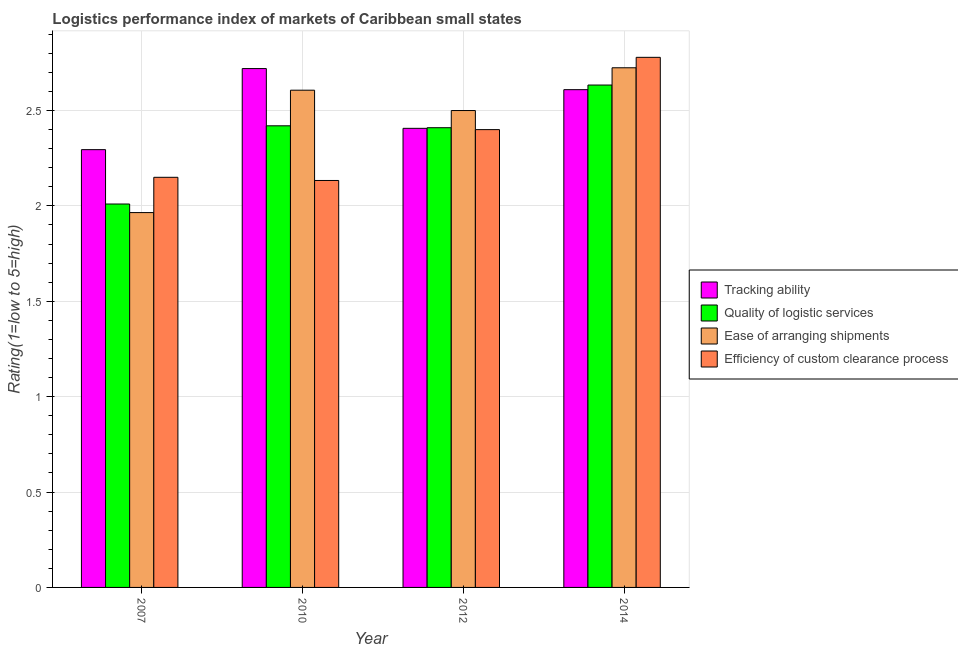How many different coloured bars are there?
Provide a succinct answer. 4. How many groups of bars are there?
Make the answer very short. 4. How many bars are there on the 4th tick from the right?
Keep it short and to the point. 4. What is the label of the 1st group of bars from the left?
Your answer should be compact. 2007. In how many cases, is the number of bars for a given year not equal to the number of legend labels?
Provide a short and direct response. 0. What is the lpi rating of quality of logistic services in 2010?
Offer a terse response. 2.42. Across all years, what is the maximum lpi rating of tracking ability?
Ensure brevity in your answer.  2.72. Across all years, what is the minimum lpi rating of quality of logistic services?
Your answer should be compact. 2.01. In which year was the lpi rating of tracking ability maximum?
Provide a short and direct response. 2010. What is the total lpi rating of efficiency of custom clearance process in the graph?
Make the answer very short. 9.46. What is the difference between the lpi rating of ease of arranging shipments in 2012 and that in 2014?
Your response must be concise. -0.22. What is the difference between the lpi rating of quality of logistic services in 2014 and the lpi rating of tracking ability in 2007?
Your response must be concise. 0.62. What is the average lpi rating of tracking ability per year?
Your answer should be very brief. 2.51. What is the ratio of the lpi rating of efficiency of custom clearance process in 2007 to that in 2012?
Your response must be concise. 0.9. Is the difference between the lpi rating of quality of logistic services in 2007 and 2012 greater than the difference between the lpi rating of efficiency of custom clearance process in 2007 and 2012?
Your answer should be compact. No. What is the difference between the highest and the second highest lpi rating of ease of arranging shipments?
Your response must be concise. 0.12. What is the difference between the highest and the lowest lpi rating of quality of logistic services?
Give a very brief answer. 0.62. In how many years, is the lpi rating of ease of arranging shipments greater than the average lpi rating of ease of arranging shipments taken over all years?
Your answer should be compact. 3. Is the sum of the lpi rating of quality of logistic services in 2010 and 2012 greater than the maximum lpi rating of ease of arranging shipments across all years?
Your answer should be very brief. Yes. What does the 3rd bar from the left in 2014 represents?
Your response must be concise. Ease of arranging shipments. What does the 3rd bar from the right in 2007 represents?
Your answer should be compact. Quality of logistic services. How many bars are there?
Your response must be concise. 16. Are all the bars in the graph horizontal?
Offer a terse response. No. Are the values on the major ticks of Y-axis written in scientific E-notation?
Provide a succinct answer. No. Does the graph contain any zero values?
Your response must be concise. No. Does the graph contain grids?
Offer a very short reply. Yes. Where does the legend appear in the graph?
Give a very brief answer. Center right. How many legend labels are there?
Offer a terse response. 4. What is the title of the graph?
Keep it short and to the point. Logistics performance index of markets of Caribbean small states. Does "Corruption" appear as one of the legend labels in the graph?
Give a very brief answer. No. What is the label or title of the Y-axis?
Make the answer very short. Rating(1=low to 5=high). What is the Rating(1=low to 5=high) in Tracking ability in 2007?
Ensure brevity in your answer.  2.29. What is the Rating(1=low to 5=high) of Quality of logistic services in 2007?
Provide a short and direct response. 2.01. What is the Rating(1=low to 5=high) in Ease of arranging shipments in 2007?
Your answer should be compact. 1.97. What is the Rating(1=low to 5=high) in Efficiency of custom clearance process in 2007?
Ensure brevity in your answer.  2.15. What is the Rating(1=low to 5=high) of Tracking ability in 2010?
Provide a short and direct response. 2.72. What is the Rating(1=low to 5=high) in Quality of logistic services in 2010?
Give a very brief answer. 2.42. What is the Rating(1=low to 5=high) of Ease of arranging shipments in 2010?
Your answer should be very brief. 2.61. What is the Rating(1=low to 5=high) in Efficiency of custom clearance process in 2010?
Offer a very short reply. 2.13. What is the Rating(1=low to 5=high) of Tracking ability in 2012?
Keep it short and to the point. 2.41. What is the Rating(1=low to 5=high) of Quality of logistic services in 2012?
Provide a short and direct response. 2.41. What is the Rating(1=low to 5=high) in Efficiency of custom clearance process in 2012?
Give a very brief answer. 2.4. What is the Rating(1=low to 5=high) of Tracking ability in 2014?
Offer a terse response. 2.61. What is the Rating(1=low to 5=high) of Quality of logistic services in 2014?
Offer a very short reply. 2.63. What is the Rating(1=low to 5=high) in Ease of arranging shipments in 2014?
Give a very brief answer. 2.72. What is the Rating(1=low to 5=high) of Efficiency of custom clearance process in 2014?
Keep it short and to the point. 2.78. Across all years, what is the maximum Rating(1=low to 5=high) in Tracking ability?
Provide a short and direct response. 2.72. Across all years, what is the maximum Rating(1=low to 5=high) in Quality of logistic services?
Provide a short and direct response. 2.63. Across all years, what is the maximum Rating(1=low to 5=high) of Ease of arranging shipments?
Keep it short and to the point. 2.72. Across all years, what is the maximum Rating(1=low to 5=high) in Efficiency of custom clearance process?
Your answer should be very brief. 2.78. Across all years, what is the minimum Rating(1=low to 5=high) of Tracking ability?
Provide a succinct answer. 2.29. Across all years, what is the minimum Rating(1=low to 5=high) of Quality of logistic services?
Keep it short and to the point. 2.01. Across all years, what is the minimum Rating(1=low to 5=high) in Ease of arranging shipments?
Provide a succinct answer. 1.97. Across all years, what is the minimum Rating(1=low to 5=high) of Efficiency of custom clearance process?
Ensure brevity in your answer.  2.13. What is the total Rating(1=low to 5=high) of Tracking ability in the graph?
Offer a terse response. 10.03. What is the total Rating(1=low to 5=high) of Quality of logistic services in the graph?
Your answer should be compact. 9.47. What is the total Rating(1=low to 5=high) in Ease of arranging shipments in the graph?
Your answer should be compact. 9.8. What is the total Rating(1=low to 5=high) of Efficiency of custom clearance process in the graph?
Provide a succinct answer. 9.46. What is the difference between the Rating(1=low to 5=high) in Tracking ability in 2007 and that in 2010?
Ensure brevity in your answer.  -0.42. What is the difference between the Rating(1=low to 5=high) of Quality of logistic services in 2007 and that in 2010?
Your answer should be very brief. -0.41. What is the difference between the Rating(1=low to 5=high) in Ease of arranging shipments in 2007 and that in 2010?
Keep it short and to the point. -0.64. What is the difference between the Rating(1=low to 5=high) of Efficiency of custom clearance process in 2007 and that in 2010?
Provide a succinct answer. 0.02. What is the difference between the Rating(1=low to 5=high) in Tracking ability in 2007 and that in 2012?
Offer a very short reply. -0.11. What is the difference between the Rating(1=low to 5=high) in Ease of arranging shipments in 2007 and that in 2012?
Ensure brevity in your answer.  -0.54. What is the difference between the Rating(1=low to 5=high) of Efficiency of custom clearance process in 2007 and that in 2012?
Give a very brief answer. -0.25. What is the difference between the Rating(1=low to 5=high) in Tracking ability in 2007 and that in 2014?
Offer a terse response. -0.31. What is the difference between the Rating(1=low to 5=high) of Quality of logistic services in 2007 and that in 2014?
Offer a terse response. -0.62. What is the difference between the Rating(1=low to 5=high) of Ease of arranging shipments in 2007 and that in 2014?
Offer a terse response. -0.76. What is the difference between the Rating(1=low to 5=high) in Efficiency of custom clearance process in 2007 and that in 2014?
Ensure brevity in your answer.  -0.63. What is the difference between the Rating(1=low to 5=high) of Tracking ability in 2010 and that in 2012?
Ensure brevity in your answer.  0.31. What is the difference between the Rating(1=low to 5=high) in Ease of arranging shipments in 2010 and that in 2012?
Make the answer very short. 0.11. What is the difference between the Rating(1=low to 5=high) in Efficiency of custom clearance process in 2010 and that in 2012?
Provide a short and direct response. -0.27. What is the difference between the Rating(1=low to 5=high) in Tracking ability in 2010 and that in 2014?
Provide a succinct answer. 0.11. What is the difference between the Rating(1=low to 5=high) in Quality of logistic services in 2010 and that in 2014?
Keep it short and to the point. -0.21. What is the difference between the Rating(1=low to 5=high) in Ease of arranging shipments in 2010 and that in 2014?
Make the answer very short. -0.12. What is the difference between the Rating(1=low to 5=high) in Efficiency of custom clearance process in 2010 and that in 2014?
Your answer should be very brief. -0.65. What is the difference between the Rating(1=low to 5=high) of Tracking ability in 2012 and that in 2014?
Your answer should be very brief. -0.2. What is the difference between the Rating(1=low to 5=high) of Quality of logistic services in 2012 and that in 2014?
Your response must be concise. -0.22. What is the difference between the Rating(1=low to 5=high) of Ease of arranging shipments in 2012 and that in 2014?
Your response must be concise. -0.22. What is the difference between the Rating(1=low to 5=high) in Efficiency of custom clearance process in 2012 and that in 2014?
Make the answer very short. -0.38. What is the difference between the Rating(1=low to 5=high) in Tracking ability in 2007 and the Rating(1=low to 5=high) in Quality of logistic services in 2010?
Your answer should be compact. -0.12. What is the difference between the Rating(1=low to 5=high) of Tracking ability in 2007 and the Rating(1=low to 5=high) of Ease of arranging shipments in 2010?
Ensure brevity in your answer.  -0.31. What is the difference between the Rating(1=low to 5=high) of Tracking ability in 2007 and the Rating(1=low to 5=high) of Efficiency of custom clearance process in 2010?
Offer a very short reply. 0.16. What is the difference between the Rating(1=low to 5=high) of Quality of logistic services in 2007 and the Rating(1=low to 5=high) of Ease of arranging shipments in 2010?
Provide a short and direct response. -0.6. What is the difference between the Rating(1=low to 5=high) in Quality of logistic services in 2007 and the Rating(1=low to 5=high) in Efficiency of custom clearance process in 2010?
Make the answer very short. -0.12. What is the difference between the Rating(1=low to 5=high) in Ease of arranging shipments in 2007 and the Rating(1=low to 5=high) in Efficiency of custom clearance process in 2010?
Make the answer very short. -0.17. What is the difference between the Rating(1=low to 5=high) in Tracking ability in 2007 and the Rating(1=low to 5=high) in Quality of logistic services in 2012?
Provide a short and direct response. -0.12. What is the difference between the Rating(1=low to 5=high) in Tracking ability in 2007 and the Rating(1=low to 5=high) in Ease of arranging shipments in 2012?
Your answer should be compact. -0.2. What is the difference between the Rating(1=low to 5=high) of Tracking ability in 2007 and the Rating(1=low to 5=high) of Efficiency of custom clearance process in 2012?
Keep it short and to the point. -0.1. What is the difference between the Rating(1=low to 5=high) of Quality of logistic services in 2007 and the Rating(1=low to 5=high) of Ease of arranging shipments in 2012?
Keep it short and to the point. -0.49. What is the difference between the Rating(1=low to 5=high) in Quality of logistic services in 2007 and the Rating(1=low to 5=high) in Efficiency of custom clearance process in 2012?
Your answer should be very brief. -0.39. What is the difference between the Rating(1=low to 5=high) in Ease of arranging shipments in 2007 and the Rating(1=low to 5=high) in Efficiency of custom clearance process in 2012?
Keep it short and to the point. -0.43. What is the difference between the Rating(1=low to 5=high) of Tracking ability in 2007 and the Rating(1=low to 5=high) of Quality of logistic services in 2014?
Ensure brevity in your answer.  -0.34. What is the difference between the Rating(1=low to 5=high) in Tracking ability in 2007 and the Rating(1=low to 5=high) in Ease of arranging shipments in 2014?
Provide a succinct answer. -0.43. What is the difference between the Rating(1=low to 5=high) of Tracking ability in 2007 and the Rating(1=low to 5=high) of Efficiency of custom clearance process in 2014?
Your answer should be very brief. -0.48. What is the difference between the Rating(1=low to 5=high) of Quality of logistic services in 2007 and the Rating(1=low to 5=high) of Ease of arranging shipments in 2014?
Your answer should be very brief. -0.71. What is the difference between the Rating(1=low to 5=high) of Quality of logistic services in 2007 and the Rating(1=low to 5=high) of Efficiency of custom clearance process in 2014?
Provide a short and direct response. -0.77. What is the difference between the Rating(1=low to 5=high) of Ease of arranging shipments in 2007 and the Rating(1=low to 5=high) of Efficiency of custom clearance process in 2014?
Offer a terse response. -0.81. What is the difference between the Rating(1=low to 5=high) in Tracking ability in 2010 and the Rating(1=low to 5=high) in Quality of logistic services in 2012?
Your response must be concise. 0.31. What is the difference between the Rating(1=low to 5=high) of Tracking ability in 2010 and the Rating(1=low to 5=high) of Ease of arranging shipments in 2012?
Ensure brevity in your answer.  0.22. What is the difference between the Rating(1=low to 5=high) in Tracking ability in 2010 and the Rating(1=low to 5=high) in Efficiency of custom clearance process in 2012?
Provide a succinct answer. 0.32. What is the difference between the Rating(1=low to 5=high) in Quality of logistic services in 2010 and the Rating(1=low to 5=high) in Ease of arranging shipments in 2012?
Provide a succinct answer. -0.08. What is the difference between the Rating(1=low to 5=high) of Ease of arranging shipments in 2010 and the Rating(1=low to 5=high) of Efficiency of custom clearance process in 2012?
Offer a very short reply. 0.21. What is the difference between the Rating(1=low to 5=high) in Tracking ability in 2010 and the Rating(1=low to 5=high) in Quality of logistic services in 2014?
Your answer should be compact. 0.09. What is the difference between the Rating(1=low to 5=high) in Tracking ability in 2010 and the Rating(1=low to 5=high) in Ease of arranging shipments in 2014?
Provide a short and direct response. -0. What is the difference between the Rating(1=low to 5=high) in Tracking ability in 2010 and the Rating(1=low to 5=high) in Efficiency of custom clearance process in 2014?
Offer a terse response. -0.06. What is the difference between the Rating(1=low to 5=high) of Quality of logistic services in 2010 and the Rating(1=low to 5=high) of Ease of arranging shipments in 2014?
Provide a short and direct response. -0.3. What is the difference between the Rating(1=low to 5=high) in Quality of logistic services in 2010 and the Rating(1=low to 5=high) in Efficiency of custom clearance process in 2014?
Ensure brevity in your answer.  -0.36. What is the difference between the Rating(1=low to 5=high) of Ease of arranging shipments in 2010 and the Rating(1=low to 5=high) of Efficiency of custom clearance process in 2014?
Your response must be concise. -0.17. What is the difference between the Rating(1=low to 5=high) of Tracking ability in 2012 and the Rating(1=low to 5=high) of Quality of logistic services in 2014?
Offer a very short reply. -0.23. What is the difference between the Rating(1=low to 5=high) in Tracking ability in 2012 and the Rating(1=low to 5=high) in Ease of arranging shipments in 2014?
Your answer should be very brief. -0.32. What is the difference between the Rating(1=low to 5=high) of Tracking ability in 2012 and the Rating(1=low to 5=high) of Efficiency of custom clearance process in 2014?
Keep it short and to the point. -0.37. What is the difference between the Rating(1=low to 5=high) in Quality of logistic services in 2012 and the Rating(1=low to 5=high) in Ease of arranging shipments in 2014?
Make the answer very short. -0.31. What is the difference between the Rating(1=low to 5=high) of Quality of logistic services in 2012 and the Rating(1=low to 5=high) of Efficiency of custom clearance process in 2014?
Make the answer very short. -0.37. What is the difference between the Rating(1=low to 5=high) of Ease of arranging shipments in 2012 and the Rating(1=low to 5=high) of Efficiency of custom clearance process in 2014?
Make the answer very short. -0.28. What is the average Rating(1=low to 5=high) in Tracking ability per year?
Your response must be concise. 2.51. What is the average Rating(1=low to 5=high) in Quality of logistic services per year?
Give a very brief answer. 2.37. What is the average Rating(1=low to 5=high) in Ease of arranging shipments per year?
Your answer should be very brief. 2.45. What is the average Rating(1=low to 5=high) of Efficiency of custom clearance process per year?
Provide a short and direct response. 2.37. In the year 2007, what is the difference between the Rating(1=low to 5=high) in Tracking ability and Rating(1=low to 5=high) in Quality of logistic services?
Offer a terse response. 0.28. In the year 2007, what is the difference between the Rating(1=low to 5=high) of Tracking ability and Rating(1=low to 5=high) of Ease of arranging shipments?
Your response must be concise. 0.33. In the year 2007, what is the difference between the Rating(1=low to 5=high) of Tracking ability and Rating(1=low to 5=high) of Efficiency of custom clearance process?
Give a very brief answer. 0.14. In the year 2007, what is the difference between the Rating(1=low to 5=high) in Quality of logistic services and Rating(1=low to 5=high) in Ease of arranging shipments?
Ensure brevity in your answer.  0.04. In the year 2007, what is the difference between the Rating(1=low to 5=high) of Quality of logistic services and Rating(1=low to 5=high) of Efficiency of custom clearance process?
Provide a short and direct response. -0.14. In the year 2007, what is the difference between the Rating(1=low to 5=high) of Ease of arranging shipments and Rating(1=low to 5=high) of Efficiency of custom clearance process?
Your answer should be very brief. -0.18. In the year 2010, what is the difference between the Rating(1=low to 5=high) of Tracking ability and Rating(1=low to 5=high) of Quality of logistic services?
Offer a terse response. 0.3. In the year 2010, what is the difference between the Rating(1=low to 5=high) in Tracking ability and Rating(1=low to 5=high) in Ease of arranging shipments?
Ensure brevity in your answer.  0.11. In the year 2010, what is the difference between the Rating(1=low to 5=high) of Tracking ability and Rating(1=low to 5=high) of Efficiency of custom clearance process?
Give a very brief answer. 0.59. In the year 2010, what is the difference between the Rating(1=low to 5=high) of Quality of logistic services and Rating(1=low to 5=high) of Ease of arranging shipments?
Your answer should be compact. -0.19. In the year 2010, what is the difference between the Rating(1=low to 5=high) of Quality of logistic services and Rating(1=low to 5=high) of Efficiency of custom clearance process?
Provide a succinct answer. 0.29. In the year 2010, what is the difference between the Rating(1=low to 5=high) in Ease of arranging shipments and Rating(1=low to 5=high) in Efficiency of custom clearance process?
Give a very brief answer. 0.47. In the year 2012, what is the difference between the Rating(1=low to 5=high) of Tracking ability and Rating(1=low to 5=high) of Quality of logistic services?
Offer a very short reply. -0. In the year 2012, what is the difference between the Rating(1=low to 5=high) of Tracking ability and Rating(1=low to 5=high) of Ease of arranging shipments?
Give a very brief answer. -0.09. In the year 2012, what is the difference between the Rating(1=low to 5=high) of Tracking ability and Rating(1=low to 5=high) of Efficiency of custom clearance process?
Your answer should be very brief. 0.01. In the year 2012, what is the difference between the Rating(1=low to 5=high) in Quality of logistic services and Rating(1=low to 5=high) in Ease of arranging shipments?
Your response must be concise. -0.09. In the year 2014, what is the difference between the Rating(1=low to 5=high) in Tracking ability and Rating(1=low to 5=high) in Quality of logistic services?
Offer a very short reply. -0.02. In the year 2014, what is the difference between the Rating(1=low to 5=high) in Tracking ability and Rating(1=low to 5=high) in Ease of arranging shipments?
Your response must be concise. -0.11. In the year 2014, what is the difference between the Rating(1=low to 5=high) in Tracking ability and Rating(1=low to 5=high) in Efficiency of custom clearance process?
Your response must be concise. -0.17. In the year 2014, what is the difference between the Rating(1=low to 5=high) of Quality of logistic services and Rating(1=low to 5=high) of Ease of arranging shipments?
Ensure brevity in your answer.  -0.09. In the year 2014, what is the difference between the Rating(1=low to 5=high) in Quality of logistic services and Rating(1=low to 5=high) in Efficiency of custom clearance process?
Provide a succinct answer. -0.15. In the year 2014, what is the difference between the Rating(1=low to 5=high) in Ease of arranging shipments and Rating(1=low to 5=high) in Efficiency of custom clearance process?
Keep it short and to the point. -0.05. What is the ratio of the Rating(1=low to 5=high) of Tracking ability in 2007 to that in 2010?
Provide a succinct answer. 0.84. What is the ratio of the Rating(1=low to 5=high) in Quality of logistic services in 2007 to that in 2010?
Provide a short and direct response. 0.83. What is the ratio of the Rating(1=low to 5=high) in Ease of arranging shipments in 2007 to that in 2010?
Ensure brevity in your answer.  0.75. What is the ratio of the Rating(1=low to 5=high) in Efficiency of custom clearance process in 2007 to that in 2010?
Give a very brief answer. 1.01. What is the ratio of the Rating(1=low to 5=high) of Tracking ability in 2007 to that in 2012?
Your response must be concise. 0.95. What is the ratio of the Rating(1=low to 5=high) in Quality of logistic services in 2007 to that in 2012?
Make the answer very short. 0.83. What is the ratio of the Rating(1=low to 5=high) of Ease of arranging shipments in 2007 to that in 2012?
Ensure brevity in your answer.  0.79. What is the ratio of the Rating(1=low to 5=high) in Efficiency of custom clearance process in 2007 to that in 2012?
Offer a very short reply. 0.9. What is the ratio of the Rating(1=low to 5=high) in Tracking ability in 2007 to that in 2014?
Your response must be concise. 0.88. What is the ratio of the Rating(1=low to 5=high) of Quality of logistic services in 2007 to that in 2014?
Provide a succinct answer. 0.76. What is the ratio of the Rating(1=low to 5=high) in Ease of arranging shipments in 2007 to that in 2014?
Make the answer very short. 0.72. What is the ratio of the Rating(1=low to 5=high) in Efficiency of custom clearance process in 2007 to that in 2014?
Make the answer very short. 0.77. What is the ratio of the Rating(1=low to 5=high) of Tracking ability in 2010 to that in 2012?
Ensure brevity in your answer.  1.13. What is the ratio of the Rating(1=low to 5=high) of Ease of arranging shipments in 2010 to that in 2012?
Provide a succinct answer. 1.04. What is the ratio of the Rating(1=low to 5=high) of Tracking ability in 2010 to that in 2014?
Offer a terse response. 1.04. What is the ratio of the Rating(1=low to 5=high) of Quality of logistic services in 2010 to that in 2014?
Keep it short and to the point. 0.92. What is the ratio of the Rating(1=low to 5=high) of Ease of arranging shipments in 2010 to that in 2014?
Provide a succinct answer. 0.96. What is the ratio of the Rating(1=low to 5=high) of Efficiency of custom clearance process in 2010 to that in 2014?
Provide a succinct answer. 0.77. What is the ratio of the Rating(1=low to 5=high) of Tracking ability in 2012 to that in 2014?
Give a very brief answer. 0.92. What is the ratio of the Rating(1=low to 5=high) in Quality of logistic services in 2012 to that in 2014?
Give a very brief answer. 0.92. What is the ratio of the Rating(1=low to 5=high) of Ease of arranging shipments in 2012 to that in 2014?
Your answer should be very brief. 0.92. What is the ratio of the Rating(1=low to 5=high) of Efficiency of custom clearance process in 2012 to that in 2014?
Provide a short and direct response. 0.86. What is the difference between the highest and the second highest Rating(1=low to 5=high) of Tracking ability?
Your response must be concise. 0.11. What is the difference between the highest and the second highest Rating(1=low to 5=high) in Quality of logistic services?
Ensure brevity in your answer.  0.21. What is the difference between the highest and the second highest Rating(1=low to 5=high) in Ease of arranging shipments?
Provide a short and direct response. 0.12. What is the difference between the highest and the second highest Rating(1=low to 5=high) of Efficiency of custom clearance process?
Provide a succinct answer. 0.38. What is the difference between the highest and the lowest Rating(1=low to 5=high) of Tracking ability?
Your answer should be very brief. 0.42. What is the difference between the highest and the lowest Rating(1=low to 5=high) in Quality of logistic services?
Your answer should be compact. 0.62. What is the difference between the highest and the lowest Rating(1=low to 5=high) in Ease of arranging shipments?
Your response must be concise. 0.76. What is the difference between the highest and the lowest Rating(1=low to 5=high) in Efficiency of custom clearance process?
Provide a succinct answer. 0.65. 